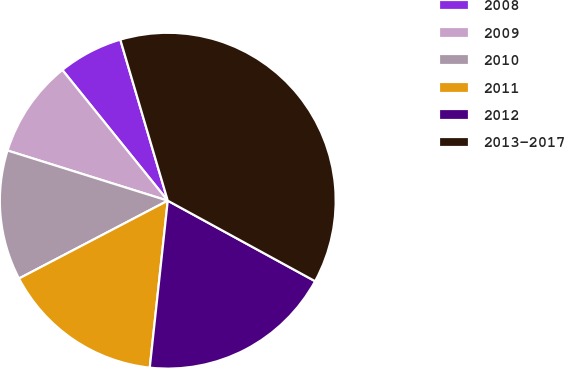Convert chart to OTSL. <chart><loc_0><loc_0><loc_500><loc_500><pie_chart><fcel>2008<fcel>2009<fcel>2010<fcel>2011<fcel>2012<fcel>2013-2017<nl><fcel>6.24%<fcel>9.37%<fcel>12.5%<fcel>15.62%<fcel>18.75%<fcel>37.52%<nl></chart> 